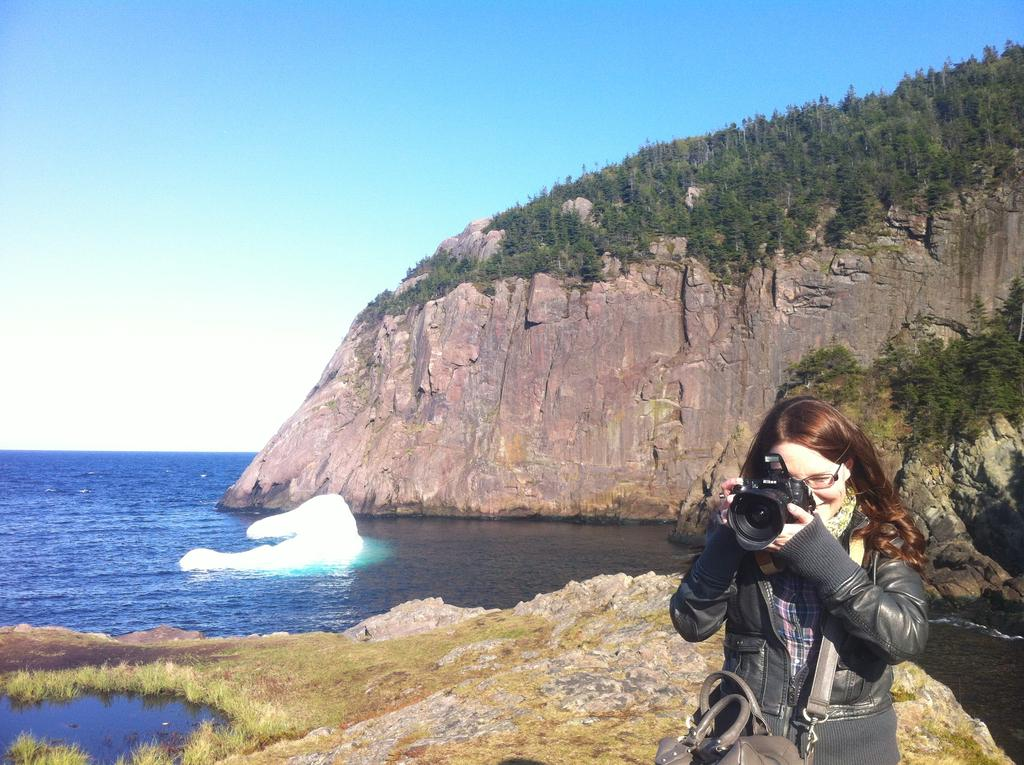What is the person in the image doing? The person is standing and holding a camera. What is the person wearing that might be used for carrying items? The person is wearing a bag. What can be seen in the distance behind the person? There is a hill, the sky, water, and trees visible in the background. How many feet are visible in the image? There are no feet visible in the image; it only shows the person from the waist up. What type of twig can be seen in the person's hand in the image? There is no twig present in the person's hand in the image; they are holding a camera. 